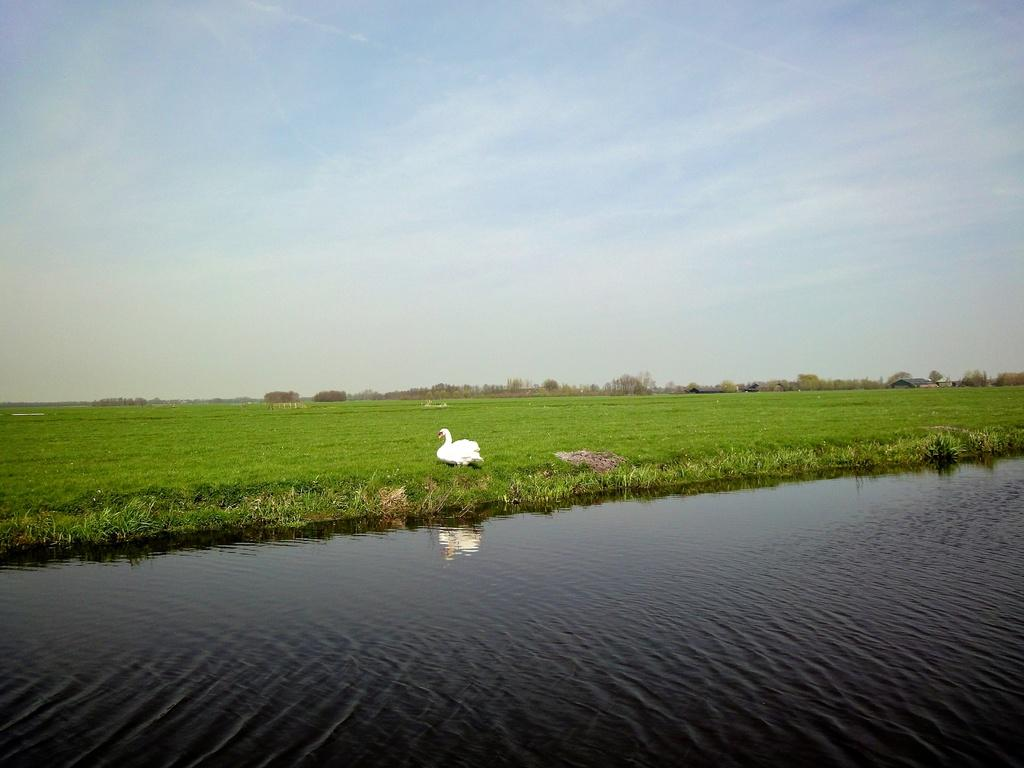What animal is in the center of the image? There is a duck in the center of the image. What type of vegetation is present in the image? There is grass in the image. What is at the bottom of the image? There is water at the bottom of the image. What can be seen at the top of the image? The sky is visible at the top of the image. What type of business is being conducted in the image? There is no indication of any business activity in the image; it features a duck, grass, water, and the sky. 